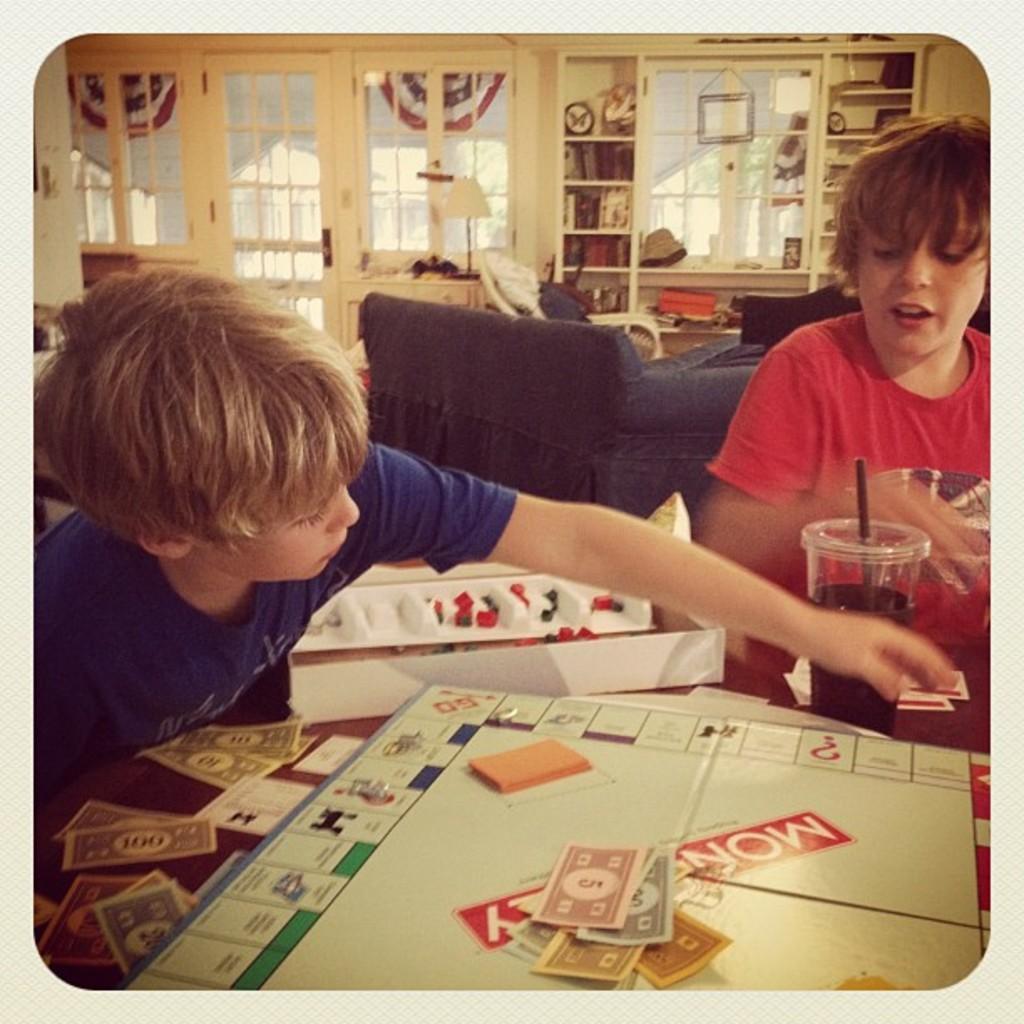Can you describe this image briefly? In this Image I see 2 boys and there is a table in front of them on which there is a board, papers and a glass. In the background I see a sofa, windows, a door and books and other things in the rack. 